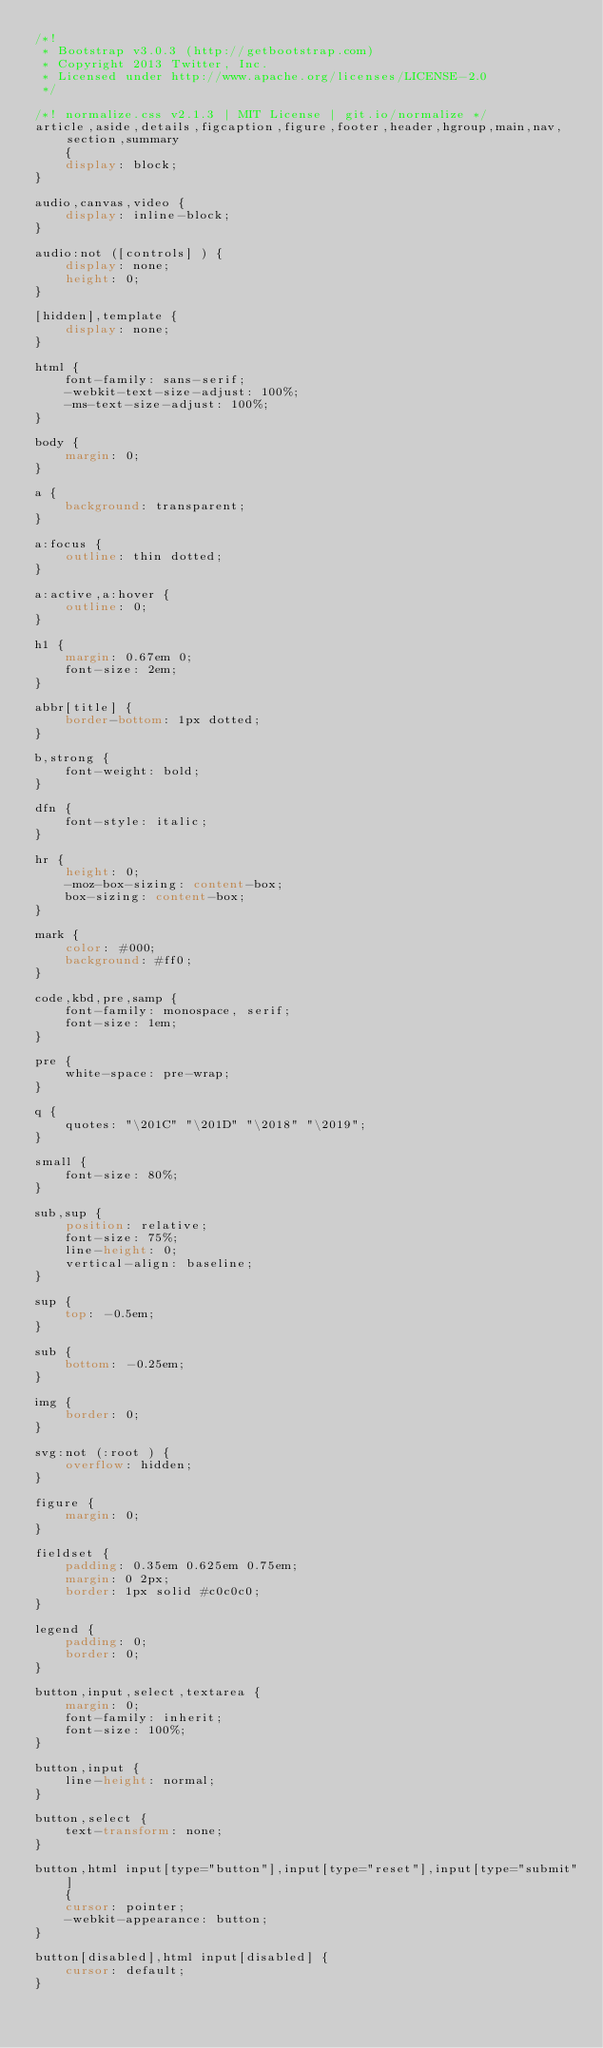Convert code to text. <code><loc_0><loc_0><loc_500><loc_500><_CSS_>/*!
 * Bootstrap v3.0.3 (http://getbootstrap.com)
 * Copyright 2013 Twitter, Inc.
 * Licensed under http://www.apache.org/licenses/LICENSE-2.0
 */

/*! normalize.css v2.1.3 | MIT License | git.io/normalize */
article,aside,details,figcaption,figure,footer,header,hgroup,main,nav,section,summary
	{
	display: block;
}

audio,canvas,video {
	display: inline-block;
}

audio:not ([controls] ) {
	display: none;
	height: 0;
}

[hidden],template {
	display: none;
}

html {
	font-family: sans-serif;
	-webkit-text-size-adjust: 100%;
	-ms-text-size-adjust: 100%;
}

body {
	margin: 0;
}

a {
	background: transparent;
}

a:focus {
	outline: thin dotted;
}

a:active,a:hover {
	outline: 0;
}

h1 {
	margin: 0.67em 0;
	font-size: 2em;
}

abbr[title] {
	border-bottom: 1px dotted;
}

b,strong {
	font-weight: bold;
}

dfn {
	font-style: italic;
}

hr {
	height: 0;
	-moz-box-sizing: content-box;
	box-sizing: content-box;
}

mark {
	color: #000;
	background: #ff0;
}

code,kbd,pre,samp {
	font-family: monospace, serif;
	font-size: 1em;
}

pre {
	white-space: pre-wrap;
}

q {
	quotes: "\201C" "\201D" "\2018" "\2019";
}

small {
	font-size: 80%;
}

sub,sup {
	position: relative;
	font-size: 75%;
	line-height: 0;
	vertical-align: baseline;
}

sup {
	top: -0.5em;
}

sub {
	bottom: -0.25em;
}

img {
	border: 0;
}

svg:not (:root ) {
	overflow: hidden;
}

figure {
	margin: 0;
}

fieldset {
	padding: 0.35em 0.625em 0.75em;
	margin: 0 2px;
	border: 1px solid #c0c0c0;
}

legend {
	padding: 0;
	border: 0;
}

button,input,select,textarea {
	margin: 0;
	font-family: inherit;
	font-size: 100%;
}

button,input {
	line-height: normal;
}

button,select {
	text-transform: none;
}

button,html input[type="button"],input[type="reset"],input[type="submit"]
	{
	cursor: pointer;
	-webkit-appearance: button;
}

button[disabled],html input[disabled] {
	cursor: default;
}
</code> 